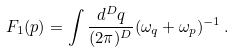<formula> <loc_0><loc_0><loc_500><loc_500>F _ { 1 } ( p ) = \int \frac { d ^ { D } q } { ( 2 \pi ) ^ { D } } ( \omega _ { q } + \omega _ { p } ) ^ { - 1 } \, .</formula> 